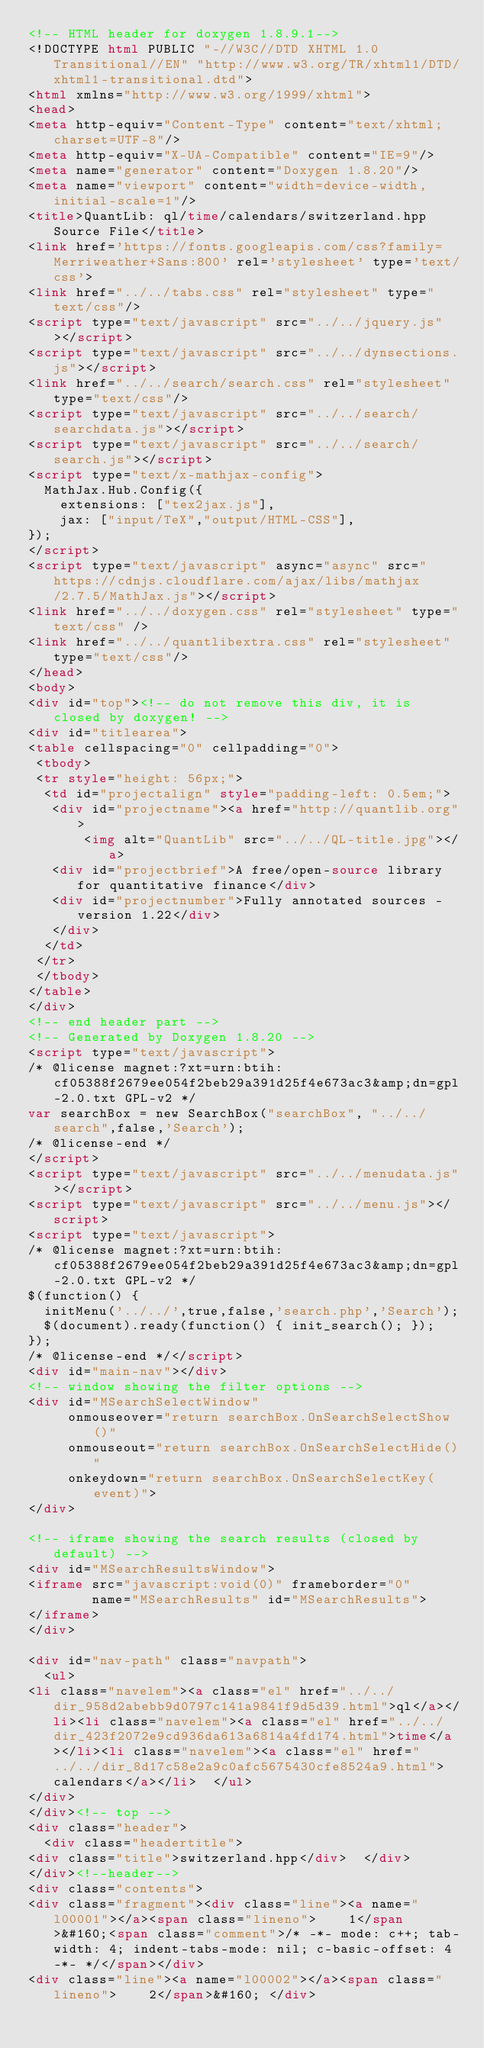Convert code to text. <code><loc_0><loc_0><loc_500><loc_500><_HTML_><!-- HTML header for doxygen 1.8.9.1-->
<!DOCTYPE html PUBLIC "-//W3C//DTD XHTML 1.0 Transitional//EN" "http://www.w3.org/TR/xhtml1/DTD/xhtml1-transitional.dtd">
<html xmlns="http://www.w3.org/1999/xhtml">
<head>
<meta http-equiv="Content-Type" content="text/xhtml;charset=UTF-8"/>
<meta http-equiv="X-UA-Compatible" content="IE=9"/>
<meta name="generator" content="Doxygen 1.8.20"/>
<meta name="viewport" content="width=device-width, initial-scale=1"/>
<title>QuantLib: ql/time/calendars/switzerland.hpp Source File</title>
<link href='https://fonts.googleapis.com/css?family=Merriweather+Sans:800' rel='stylesheet' type='text/css'>
<link href="../../tabs.css" rel="stylesheet" type="text/css"/>
<script type="text/javascript" src="../../jquery.js"></script>
<script type="text/javascript" src="../../dynsections.js"></script>
<link href="../../search/search.css" rel="stylesheet" type="text/css"/>
<script type="text/javascript" src="../../search/searchdata.js"></script>
<script type="text/javascript" src="../../search/search.js"></script>
<script type="text/x-mathjax-config">
  MathJax.Hub.Config({
    extensions: ["tex2jax.js"],
    jax: ["input/TeX","output/HTML-CSS"],
});
</script>
<script type="text/javascript" async="async" src="https://cdnjs.cloudflare.com/ajax/libs/mathjax/2.7.5/MathJax.js"></script>
<link href="../../doxygen.css" rel="stylesheet" type="text/css" />
<link href="../../quantlibextra.css" rel="stylesheet" type="text/css"/>
</head>
<body>
<div id="top"><!-- do not remove this div, it is closed by doxygen! -->
<div id="titlearea">
<table cellspacing="0" cellpadding="0">
 <tbody>
 <tr style="height: 56px;">
  <td id="projectalign" style="padding-left: 0.5em;">
   <div id="projectname"><a href="http://quantlib.org">
       <img alt="QuantLib" src="../../QL-title.jpg"></a>
   <div id="projectbrief">A free/open-source library for quantitative finance</div>
   <div id="projectnumber">Fully annotated sources - version 1.22</div>
   </div>
  </td>
 </tr>
 </tbody>
</table>
</div>
<!-- end header part -->
<!-- Generated by Doxygen 1.8.20 -->
<script type="text/javascript">
/* @license magnet:?xt=urn:btih:cf05388f2679ee054f2beb29a391d25f4e673ac3&amp;dn=gpl-2.0.txt GPL-v2 */
var searchBox = new SearchBox("searchBox", "../../search",false,'Search');
/* @license-end */
</script>
<script type="text/javascript" src="../../menudata.js"></script>
<script type="text/javascript" src="../../menu.js"></script>
<script type="text/javascript">
/* @license magnet:?xt=urn:btih:cf05388f2679ee054f2beb29a391d25f4e673ac3&amp;dn=gpl-2.0.txt GPL-v2 */
$(function() {
  initMenu('../../',true,false,'search.php','Search');
  $(document).ready(function() { init_search(); });
});
/* @license-end */</script>
<div id="main-nav"></div>
<!-- window showing the filter options -->
<div id="MSearchSelectWindow"
     onmouseover="return searchBox.OnSearchSelectShow()"
     onmouseout="return searchBox.OnSearchSelectHide()"
     onkeydown="return searchBox.OnSearchSelectKey(event)">
</div>

<!-- iframe showing the search results (closed by default) -->
<div id="MSearchResultsWindow">
<iframe src="javascript:void(0)" frameborder="0" 
        name="MSearchResults" id="MSearchResults">
</iframe>
</div>

<div id="nav-path" class="navpath">
  <ul>
<li class="navelem"><a class="el" href="../../dir_958d2abebb9d0797c141a9841f9d5d39.html">ql</a></li><li class="navelem"><a class="el" href="../../dir_423f2072e9cd936da613a6814a4fd174.html">time</a></li><li class="navelem"><a class="el" href="../../dir_8d17c58e2a9c0afc5675430cfe8524a9.html">calendars</a></li>  </ul>
</div>
</div><!-- top -->
<div class="header">
  <div class="headertitle">
<div class="title">switzerland.hpp</div>  </div>
</div><!--header-->
<div class="contents">
<div class="fragment"><div class="line"><a name="l00001"></a><span class="lineno">    1</span>&#160;<span class="comment">/* -*- mode: c++; tab-width: 4; indent-tabs-mode: nil; c-basic-offset: 4 -*- */</span></div>
<div class="line"><a name="l00002"></a><span class="lineno">    2</span>&#160; </div></code> 